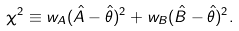Convert formula to latex. <formula><loc_0><loc_0><loc_500><loc_500>\chi ^ { 2 } \equiv w _ { A } ( \hat { A } - \hat { \theta } ) ^ { 2 } + w _ { B } ( \hat { B } - \hat { \theta } ) ^ { 2 } .</formula> 